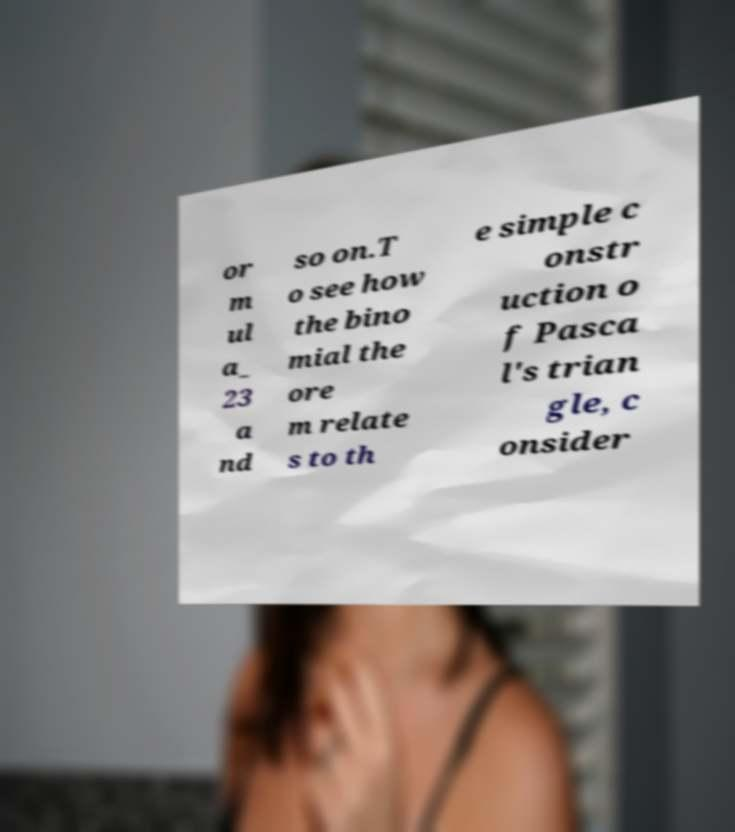Please identify and transcribe the text found in this image. or m ul a_ 23 a nd so on.T o see how the bino mial the ore m relate s to th e simple c onstr uction o f Pasca l's trian gle, c onsider 